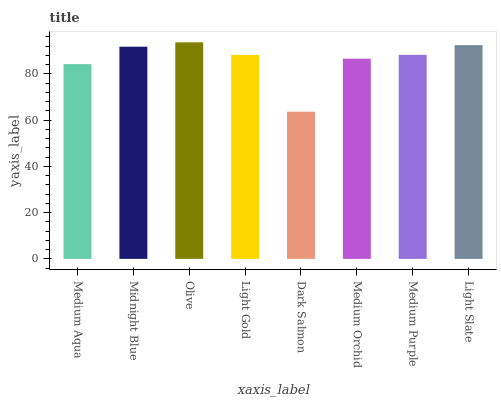Is Dark Salmon the minimum?
Answer yes or no. Yes. Is Olive the maximum?
Answer yes or no. Yes. Is Midnight Blue the minimum?
Answer yes or no. No. Is Midnight Blue the maximum?
Answer yes or no. No. Is Midnight Blue greater than Medium Aqua?
Answer yes or no. Yes. Is Medium Aqua less than Midnight Blue?
Answer yes or no. Yes. Is Medium Aqua greater than Midnight Blue?
Answer yes or no. No. Is Midnight Blue less than Medium Aqua?
Answer yes or no. No. Is Medium Purple the high median?
Answer yes or no. Yes. Is Light Gold the low median?
Answer yes or no. Yes. Is Olive the high median?
Answer yes or no. No. Is Medium Orchid the low median?
Answer yes or no. No. 